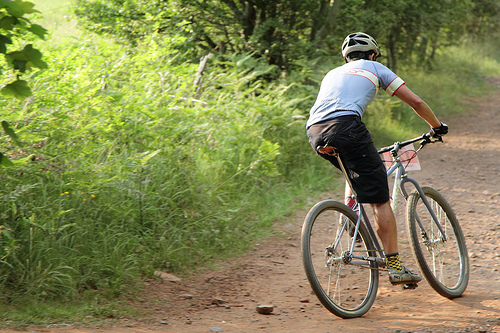<image>
Is the bike in the grass? No. The bike is not contained within the grass. These objects have a different spatial relationship. Is there a cycle in the plants? No. The cycle is not contained within the plants. These objects have a different spatial relationship. 